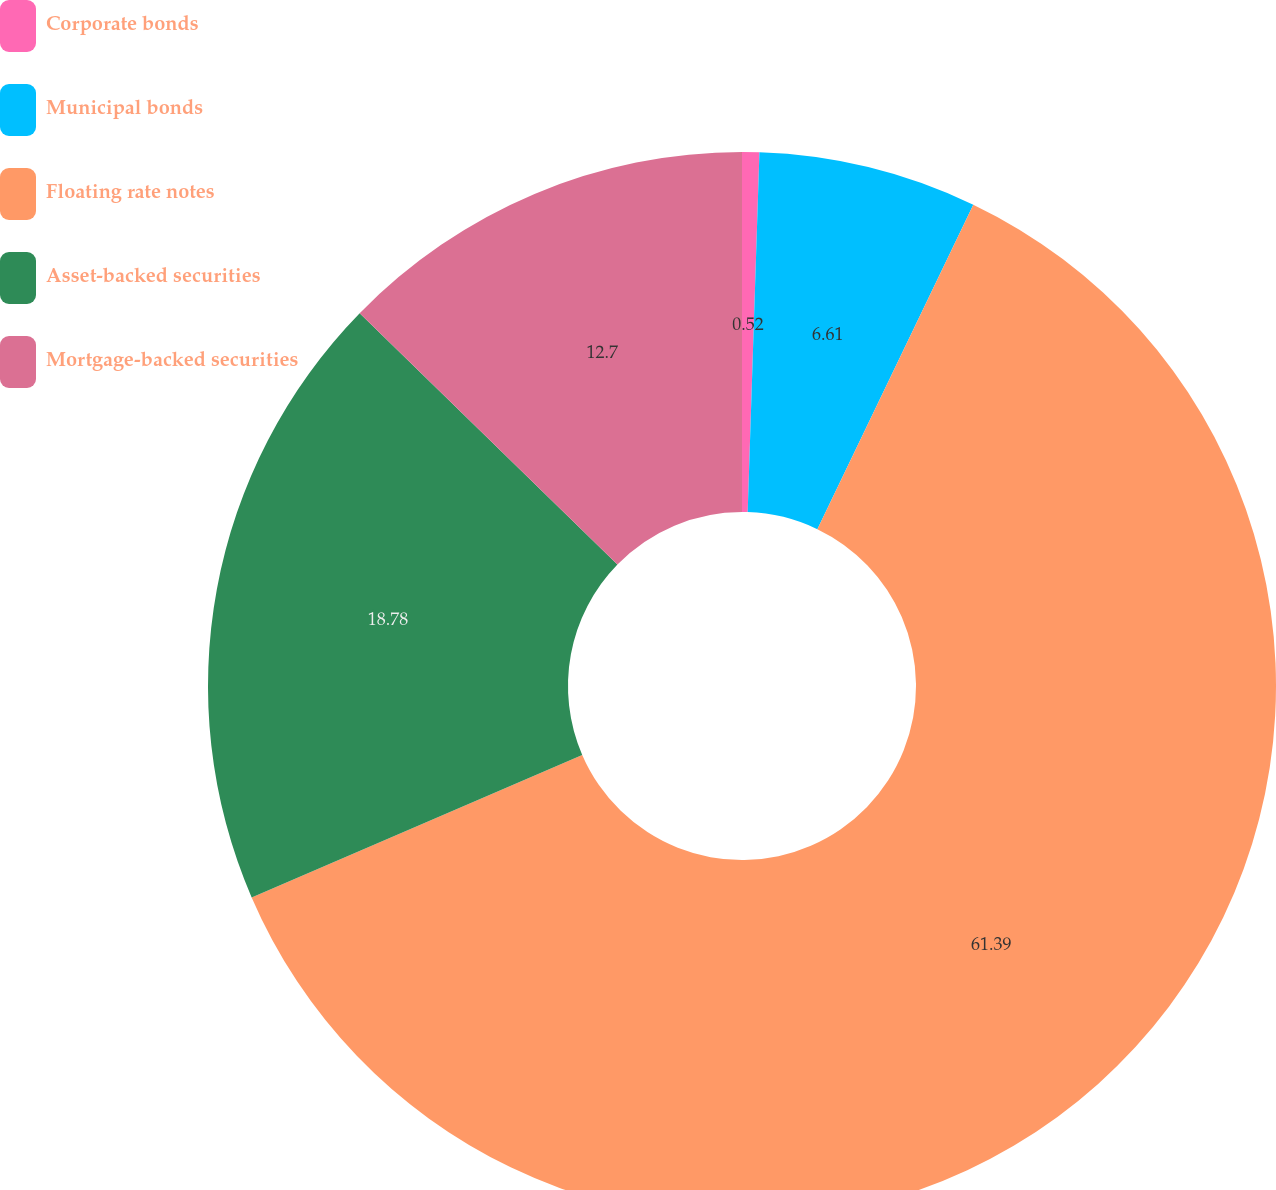Convert chart to OTSL. <chart><loc_0><loc_0><loc_500><loc_500><pie_chart><fcel>Corporate bonds<fcel>Municipal bonds<fcel>Floating rate notes<fcel>Asset-backed securities<fcel>Mortgage-backed securities<nl><fcel>0.52%<fcel>6.61%<fcel>61.39%<fcel>18.78%<fcel>12.7%<nl></chart> 